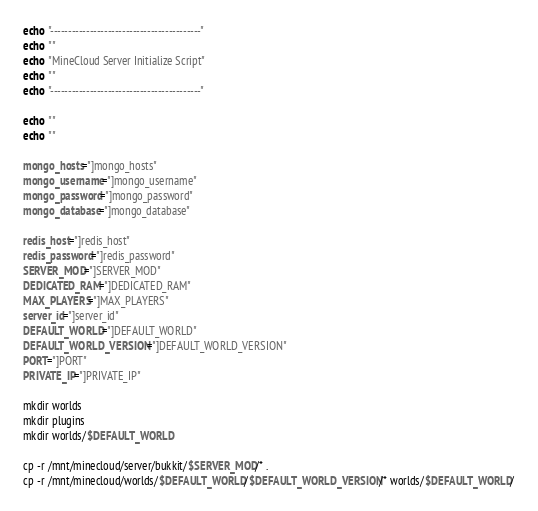<code> <loc_0><loc_0><loc_500><loc_500><_Bash_>
echo "------------------------------------------"
echo ""
echo "MineCloud Server Initialize Script"
echo ""
echo "------------------------------------------"

echo ""
echo ""

mongo_hosts="]mongo_hosts"
mongo_username="]mongo_username"
mongo_password="]mongo_password"
mongo_database="]mongo_database"

redis_host="]redis_host"
redis_password="]redis_password"
SERVER_MOD="]SERVER_MOD"
DEDICATED_RAM="]DEDICATED_RAM"
MAX_PLAYERS="]MAX_PLAYERS"
server_id="]server_id"
DEFAULT_WORLD="]DEFAULT_WORLD"
DEFAULT_WORLD_VERSION="]DEFAULT_WORLD_VERSION"
PORT="]PORT"
PRIVATE_IP="]PRIVATE_IP"

mkdir worlds
mkdir plugins
mkdir worlds/$DEFAULT_WORLD

cp -r /mnt/minecloud/server/bukkit/$SERVER_MOD/* .
cp -r /mnt/minecloud/worlds/$DEFAULT_WORLD/$DEFAULT_WORLD_VERSION/* worlds/$DEFAULT_WORLD/</code> 